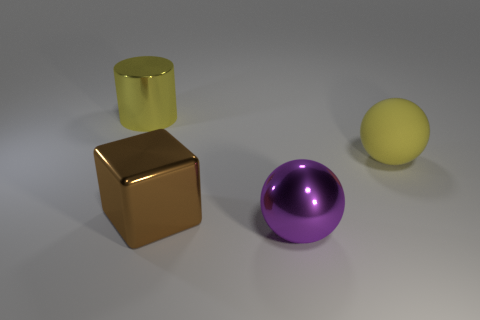Add 4 small purple metallic blocks. How many objects exist? 8 Subtract all cubes. How many objects are left? 3 Add 2 big brown metal things. How many big brown metal things are left? 3 Add 3 red rubber blocks. How many red rubber blocks exist? 3 Subtract 0 blue balls. How many objects are left? 4 Subtract all large metal things. Subtract all yellow shiny objects. How many objects are left? 0 